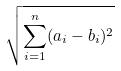<formula> <loc_0><loc_0><loc_500><loc_500>\sqrt { \sum _ { i = 1 } ^ { n } ( a _ { i } - b _ { i } ) ^ { 2 } }</formula> 